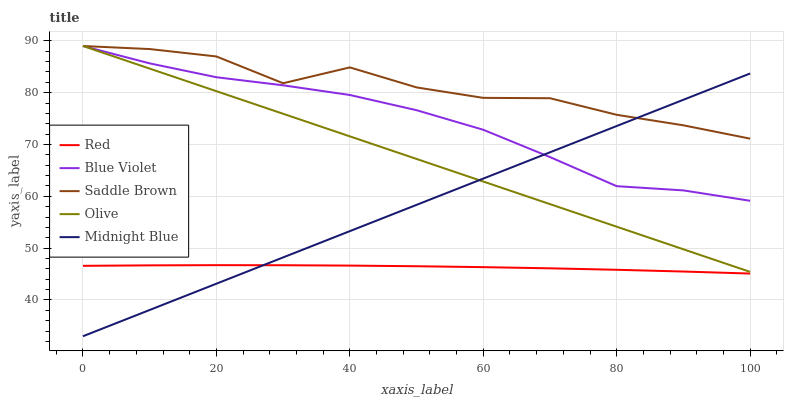Does Red have the minimum area under the curve?
Answer yes or no. Yes. Does Saddle Brown have the maximum area under the curve?
Answer yes or no. Yes. Does Midnight Blue have the minimum area under the curve?
Answer yes or no. No. Does Midnight Blue have the maximum area under the curve?
Answer yes or no. No. Is Midnight Blue the smoothest?
Answer yes or no. Yes. Is Saddle Brown the roughest?
Answer yes or no. Yes. Is Blue Violet the smoothest?
Answer yes or no. No. Is Blue Violet the roughest?
Answer yes or no. No. Does Midnight Blue have the lowest value?
Answer yes or no. Yes. Does Blue Violet have the lowest value?
Answer yes or no. No. Does Saddle Brown have the highest value?
Answer yes or no. Yes. Does Midnight Blue have the highest value?
Answer yes or no. No. Is Red less than Saddle Brown?
Answer yes or no. Yes. Is Olive greater than Red?
Answer yes or no. Yes. Does Midnight Blue intersect Blue Violet?
Answer yes or no. Yes. Is Midnight Blue less than Blue Violet?
Answer yes or no. No. Is Midnight Blue greater than Blue Violet?
Answer yes or no. No. Does Red intersect Saddle Brown?
Answer yes or no. No. 